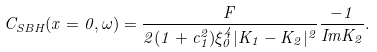Convert formula to latex. <formula><loc_0><loc_0><loc_500><loc_500>C _ { S B H } ( x = 0 , \omega ) = \frac { F } { 2 ( 1 + c _ { 1 } ^ { 2 } ) \xi _ { 0 } ^ { 4 } | K _ { 1 } - K _ { 2 } | ^ { 2 } } \frac { - 1 } { I m K _ { 2 } } .</formula> 